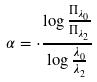Convert formula to latex. <formula><loc_0><loc_0><loc_500><loc_500>\alpha = \cdot \frac { \log \frac { \Pi _ { \lambda _ { 0 } } } { \Pi _ { \lambda _ { 2 } } } } { \log \frac { \lambda _ { 0 } } { \lambda _ { 2 } } }</formula> 